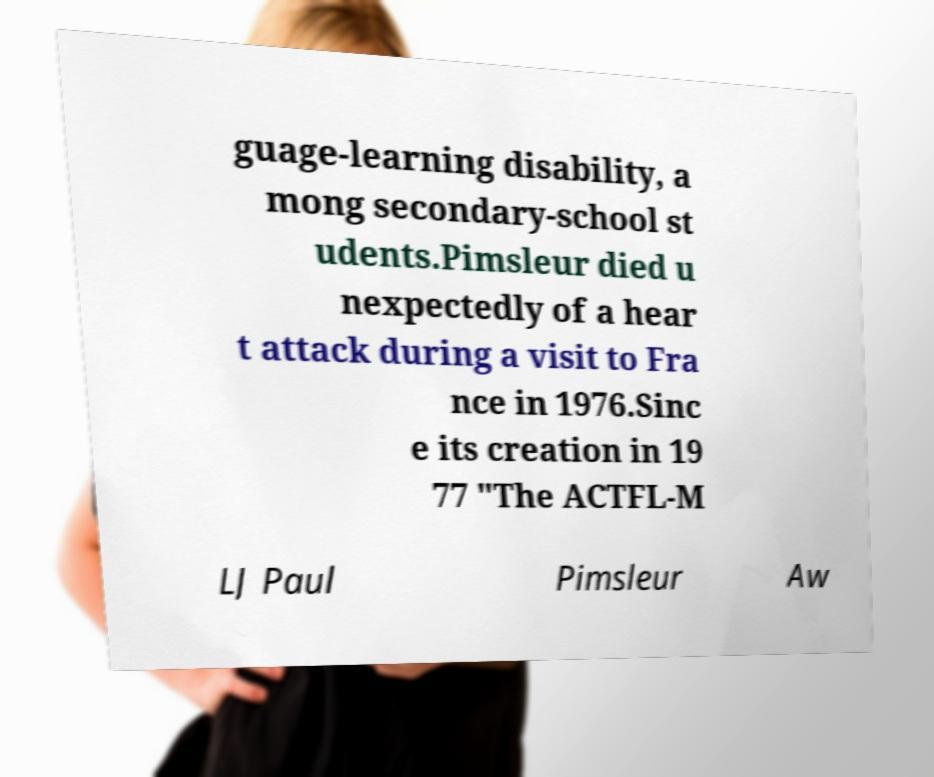Can you read and provide the text displayed in the image?This photo seems to have some interesting text. Can you extract and type it out for me? guage-learning disability, a mong secondary-school st udents.Pimsleur died u nexpectedly of a hear t attack during a visit to Fra nce in 1976.Sinc e its creation in 19 77 "The ACTFL-M LJ Paul Pimsleur Aw 